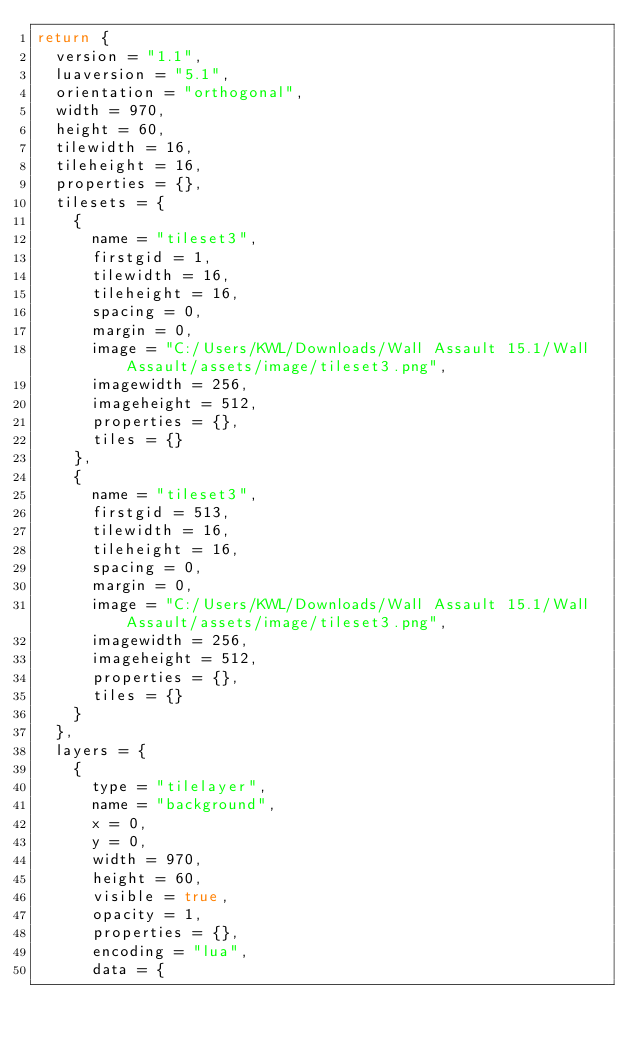Convert code to text. <code><loc_0><loc_0><loc_500><loc_500><_Lua_>return {
  version = "1.1",
  luaversion = "5.1",
  orientation = "orthogonal",
  width = 970,
  height = 60,
  tilewidth = 16,
  tileheight = 16,
  properties = {},
  tilesets = {
    {
      name = "tileset3",
      firstgid = 1,
      tilewidth = 16,
      tileheight = 16,
      spacing = 0,
      margin = 0,
      image = "C:/Users/KWL/Downloads/Wall Assault 15.1/Wall Assault/assets/image/tileset3.png",
      imagewidth = 256,
      imageheight = 512,
      properties = {},
      tiles = {}
    },
    {
      name = "tileset3",
      firstgid = 513,
      tilewidth = 16,
      tileheight = 16,
      spacing = 0,
      margin = 0,
      image = "C:/Users/KWL/Downloads/Wall Assault 15.1/Wall Assault/assets/image/tileset3.png",
      imagewidth = 256,
      imageheight = 512,
      properties = {},
      tiles = {}
    }
  },
  layers = {
    {
      type = "tilelayer",
      name = "background",
      x = 0,
      y = 0,
      width = 970,
      height = 60,
      visible = true,
      opacity = 1,
      properties = {},
      encoding = "lua",
      data = {</code> 